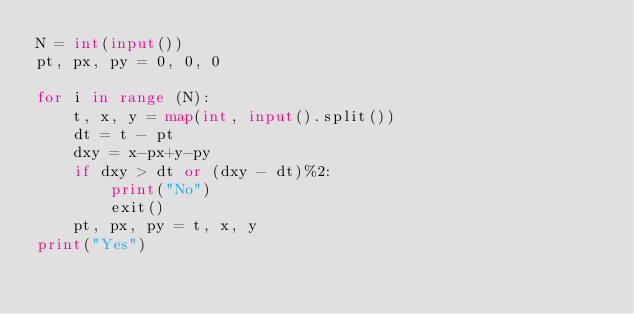Convert code to text. <code><loc_0><loc_0><loc_500><loc_500><_Python_>N = int(input())
pt, px, py = 0, 0, 0

for i in range (N):
    t, x, y = map(int, input().split())
    dt = t - pt
    dxy = x-px+y-py
    if dxy > dt or (dxy - dt)%2:
        print("No")
        exit()
    pt, px, py = t, x, y
print("Yes")</code> 